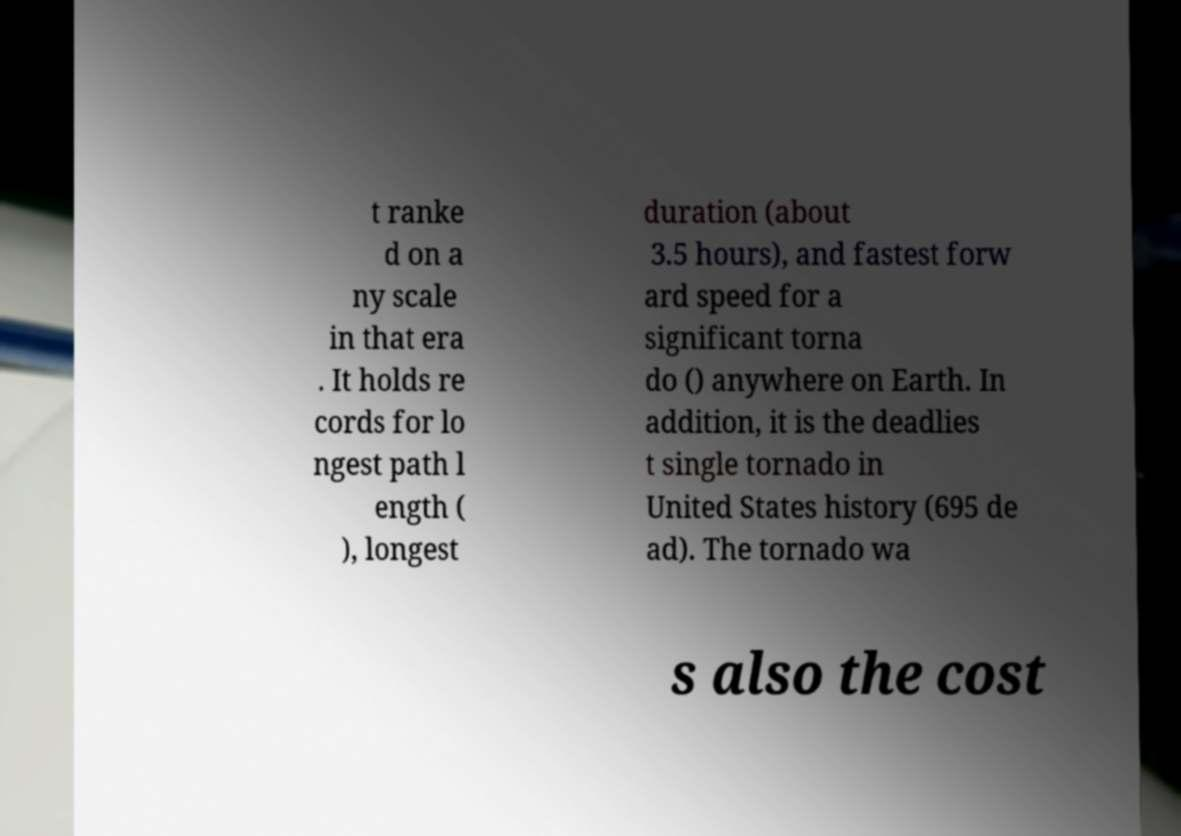What messages or text are displayed in this image? I need them in a readable, typed format. t ranke d on a ny scale in that era . It holds re cords for lo ngest path l ength ( ), longest duration (about 3.5 hours), and fastest forw ard speed for a significant torna do () anywhere on Earth. In addition, it is the deadlies t single tornado in United States history (695 de ad). The tornado wa s also the cost 